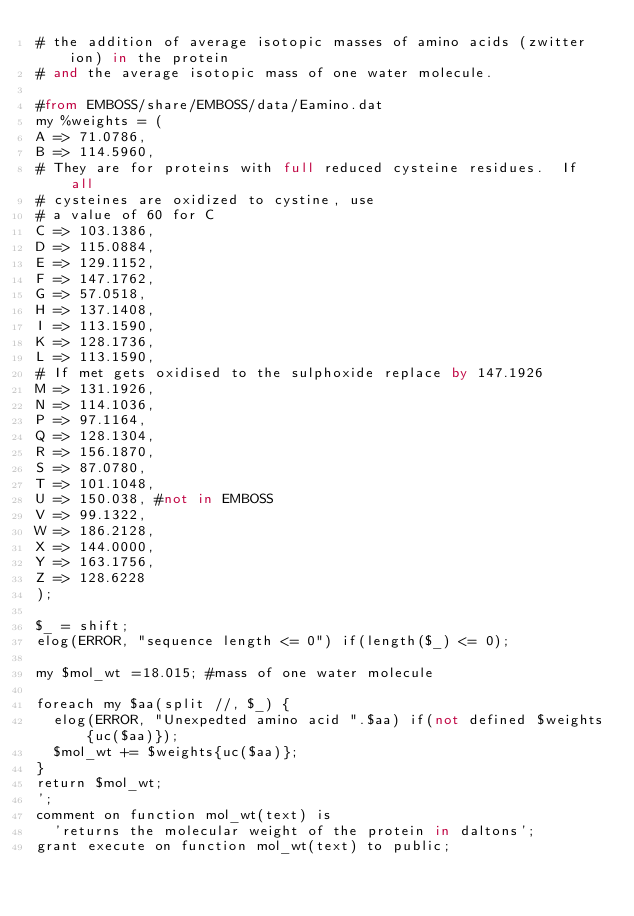Convert code to text. <code><loc_0><loc_0><loc_500><loc_500><_SQL_># the addition of average isotopic masses of amino acids (zwitter ion) in the protein 
# and the average isotopic mass of one water molecule.

#from EMBOSS/share/EMBOSS/data/Eamino.dat
my %weights = (
A => 71.0786,
B => 114.5960,
# They are for proteins with full reduced cysteine residues.  If all
# cysteines are oxidized to cystine, use
# a value of 60 for C
C => 103.1386,
D => 115.0884,
E => 129.1152,
F => 147.1762,
G => 57.0518,
H => 137.1408,
I => 113.1590,
K => 128.1736,
L => 113.1590,
# If met gets oxidised to the sulphoxide replace by 147.1926
M => 131.1926,
N => 114.1036,
P => 97.1164,
Q => 128.1304,
R => 156.1870,
S => 87.0780,
T => 101.1048,
U => 150.038, #not in EMBOSS
V => 99.1322,
W => 186.2128,
X => 144.0000,
Y => 163.1756,
Z => 128.6228
);

$_ = shift;
elog(ERROR, "sequence length <= 0") if(length($_) <= 0);

my $mol_wt =18.015; #mass of one water molecule

foreach my $aa(split //, $_) {
	elog(ERROR, "Unexpedted amino acid ".$aa) if(not defined $weights{uc($aa)});
	$mol_wt += $weights{uc($aa)};
}	
return $mol_wt;
';
comment on function mol_wt(text) is
	'returns the molecular weight of the protein in daltons';
grant execute on function mol_wt(text) to public;

</code> 